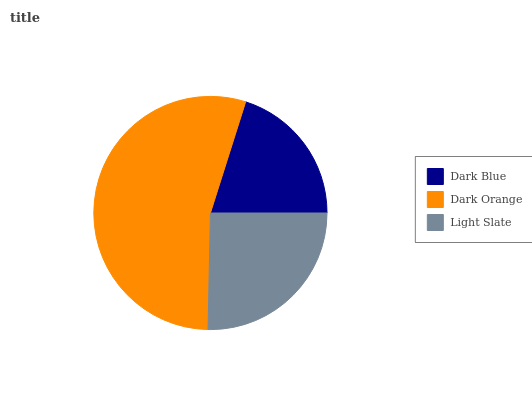Is Dark Blue the minimum?
Answer yes or no. Yes. Is Dark Orange the maximum?
Answer yes or no. Yes. Is Light Slate the minimum?
Answer yes or no. No. Is Light Slate the maximum?
Answer yes or no. No. Is Dark Orange greater than Light Slate?
Answer yes or no. Yes. Is Light Slate less than Dark Orange?
Answer yes or no. Yes. Is Light Slate greater than Dark Orange?
Answer yes or no. No. Is Dark Orange less than Light Slate?
Answer yes or no. No. Is Light Slate the high median?
Answer yes or no. Yes. Is Light Slate the low median?
Answer yes or no. Yes. Is Dark Blue the high median?
Answer yes or no. No. Is Dark Blue the low median?
Answer yes or no. No. 